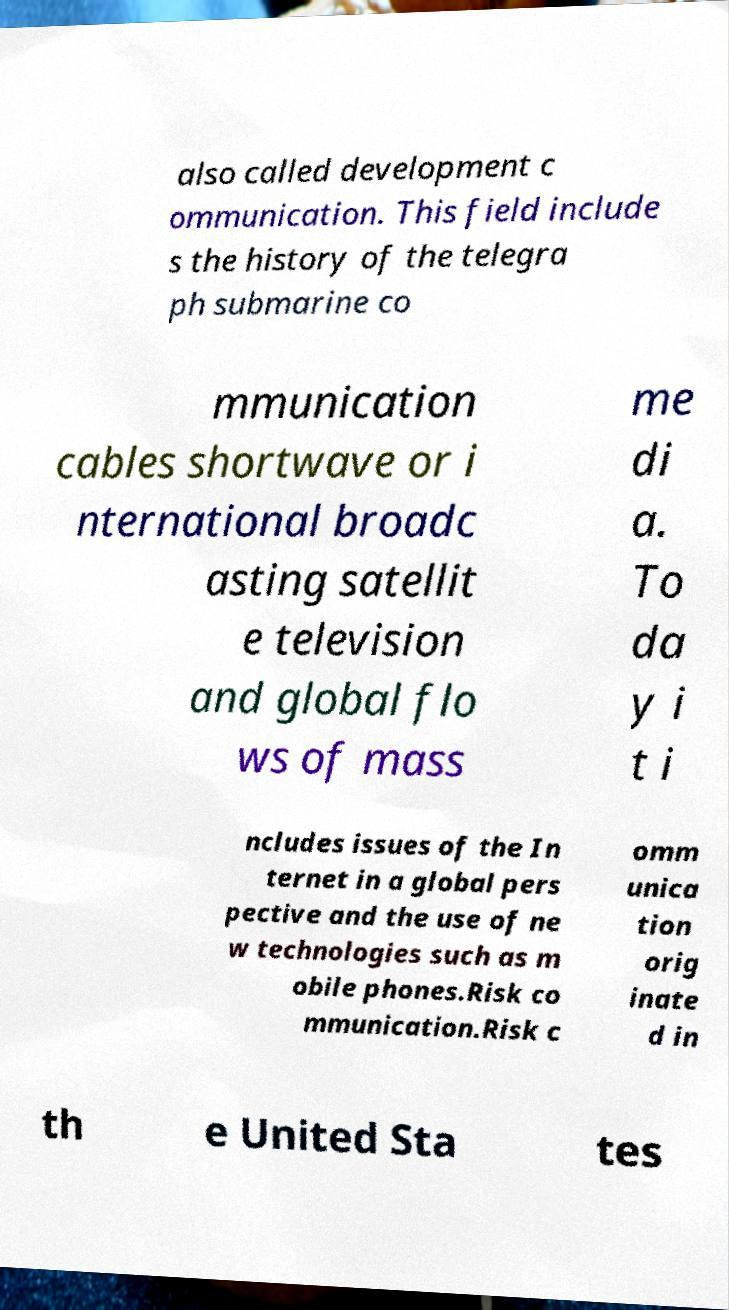Please identify and transcribe the text found in this image. also called development c ommunication. This field include s the history of the telegra ph submarine co mmunication cables shortwave or i nternational broadc asting satellit e television and global flo ws of mass me di a. To da y i t i ncludes issues of the In ternet in a global pers pective and the use of ne w technologies such as m obile phones.Risk co mmunication.Risk c omm unica tion orig inate d in th e United Sta tes 